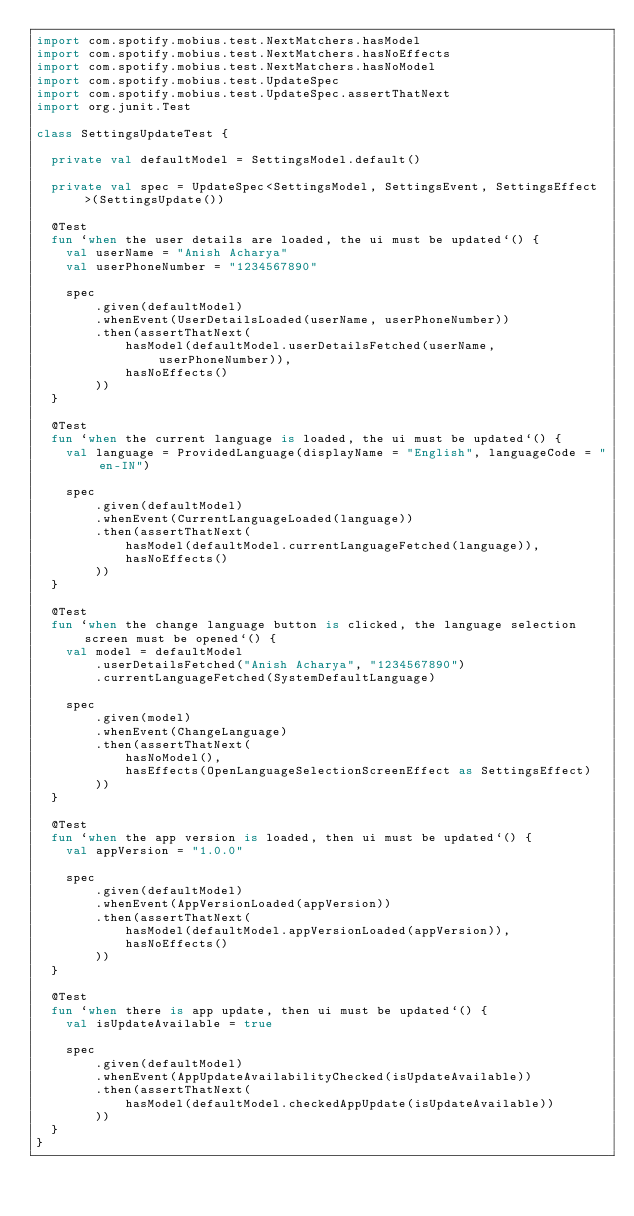<code> <loc_0><loc_0><loc_500><loc_500><_Kotlin_>import com.spotify.mobius.test.NextMatchers.hasModel
import com.spotify.mobius.test.NextMatchers.hasNoEffects
import com.spotify.mobius.test.NextMatchers.hasNoModel
import com.spotify.mobius.test.UpdateSpec
import com.spotify.mobius.test.UpdateSpec.assertThatNext
import org.junit.Test

class SettingsUpdateTest {

  private val defaultModel = SettingsModel.default()

  private val spec = UpdateSpec<SettingsModel, SettingsEvent, SettingsEffect>(SettingsUpdate())

  @Test
  fun `when the user details are loaded, the ui must be updated`() {
    val userName = "Anish Acharya"
    val userPhoneNumber = "1234567890"

    spec
        .given(defaultModel)
        .whenEvent(UserDetailsLoaded(userName, userPhoneNumber))
        .then(assertThatNext(
            hasModel(defaultModel.userDetailsFetched(userName, userPhoneNumber)),
            hasNoEffects()
        ))
  }

  @Test
  fun `when the current language is loaded, the ui must be updated`() {
    val language = ProvidedLanguage(displayName = "English", languageCode = "en-IN")

    spec
        .given(defaultModel)
        .whenEvent(CurrentLanguageLoaded(language))
        .then(assertThatNext(
            hasModel(defaultModel.currentLanguageFetched(language)),
            hasNoEffects()
        ))
  }

  @Test
  fun `when the change language button is clicked, the language selection screen must be opened`() {
    val model = defaultModel
        .userDetailsFetched("Anish Acharya", "1234567890")
        .currentLanguageFetched(SystemDefaultLanguage)

    spec
        .given(model)
        .whenEvent(ChangeLanguage)
        .then(assertThatNext(
            hasNoModel(),
            hasEffects(OpenLanguageSelectionScreenEffect as SettingsEffect)
        ))
  }

  @Test
  fun `when the app version is loaded, then ui must be updated`() {
    val appVersion = "1.0.0"

    spec
        .given(defaultModel)
        .whenEvent(AppVersionLoaded(appVersion))
        .then(assertThatNext(
            hasModel(defaultModel.appVersionLoaded(appVersion)),
            hasNoEffects()
        ))
  }

  @Test
  fun `when there is app update, then ui must be updated`() {
    val isUpdateAvailable = true

    spec
        .given(defaultModel)
        .whenEvent(AppUpdateAvailabilityChecked(isUpdateAvailable))
        .then(assertThatNext(
            hasModel(defaultModel.checkedAppUpdate(isUpdateAvailable))
        ))
  }
}
</code> 